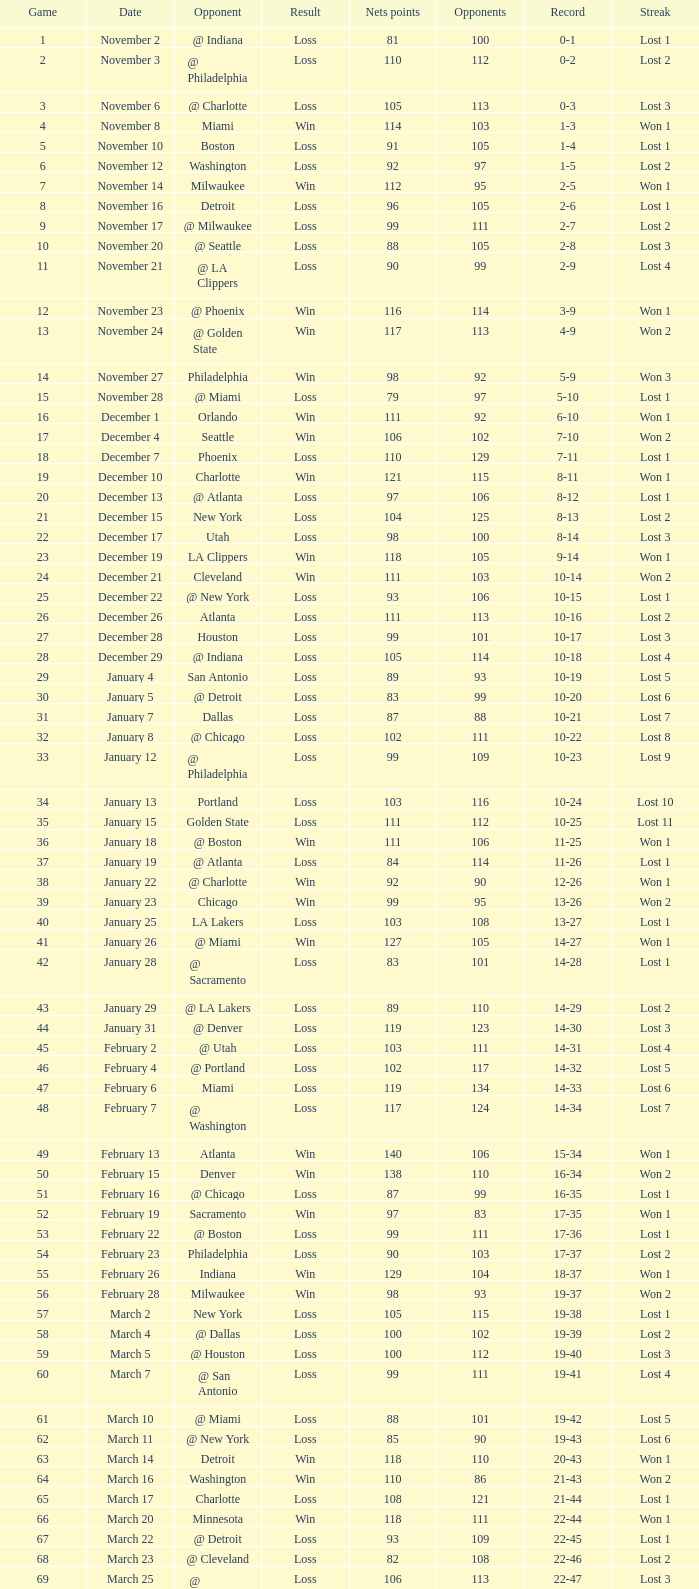Could you parse the entire table as a dict? {'header': ['Game', 'Date', 'Opponent', 'Result', 'Nets points', 'Opponents', 'Record', 'Streak'], 'rows': [['1', 'November 2', '@ Indiana', 'Loss', '81', '100', '0-1', 'Lost 1'], ['2', 'November 3', '@ Philadelphia', 'Loss', '110', '112', '0-2', 'Lost 2'], ['3', 'November 6', '@ Charlotte', 'Loss', '105', '113', '0-3', 'Lost 3'], ['4', 'November 8', 'Miami', 'Win', '114', '103', '1-3', 'Won 1'], ['5', 'November 10', 'Boston', 'Loss', '91', '105', '1-4', 'Lost 1'], ['6', 'November 12', 'Washington', 'Loss', '92', '97', '1-5', 'Lost 2'], ['7', 'November 14', 'Milwaukee', 'Win', '112', '95', '2-5', 'Won 1'], ['8', 'November 16', 'Detroit', 'Loss', '96', '105', '2-6', 'Lost 1'], ['9', 'November 17', '@ Milwaukee', 'Loss', '99', '111', '2-7', 'Lost 2'], ['10', 'November 20', '@ Seattle', 'Loss', '88', '105', '2-8', 'Lost 3'], ['11', 'November 21', '@ LA Clippers', 'Loss', '90', '99', '2-9', 'Lost 4'], ['12', 'November 23', '@ Phoenix', 'Win', '116', '114', '3-9', 'Won 1'], ['13', 'November 24', '@ Golden State', 'Win', '117', '113', '4-9', 'Won 2'], ['14', 'November 27', 'Philadelphia', 'Win', '98', '92', '5-9', 'Won 3'], ['15', 'November 28', '@ Miami', 'Loss', '79', '97', '5-10', 'Lost 1'], ['16', 'December 1', 'Orlando', 'Win', '111', '92', '6-10', 'Won 1'], ['17', 'December 4', 'Seattle', 'Win', '106', '102', '7-10', 'Won 2'], ['18', 'December 7', 'Phoenix', 'Loss', '110', '129', '7-11', 'Lost 1'], ['19', 'December 10', 'Charlotte', 'Win', '121', '115', '8-11', 'Won 1'], ['20', 'December 13', '@ Atlanta', 'Loss', '97', '106', '8-12', 'Lost 1'], ['21', 'December 15', 'New York', 'Loss', '104', '125', '8-13', 'Lost 2'], ['22', 'December 17', 'Utah', 'Loss', '98', '100', '8-14', 'Lost 3'], ['23', 'December 19', 'LA Clippers', 'Win', '118', '105', '9-14', 'Won 1'], ['24', 'December 21', 'Cleveland', 'Win', '111', '103', '10-14', 'Won 2'], ['25', 'December 22', '@ New York', 'Loss', '93', '106', '10-15', 'Lost 1'], ['26', 'December 26', 'Atlanta', 'Loss', '111', '113', '10-16', 'Lost 2'], ['27', 'December 28', 'Houston', 'Loss', '99', '101', '10-17', 'Lost 3'], ['28', 'December 29', '@ Indiana', 'Loss', '105', '114', '10-18', 'Lost 4'], ['29', 'January 4', 'San Antonio', 'Loss', '89', '93', '10-19', 'Lost 5'], ['30', 'January 5', '@ Detroit', 'Loss', '83', '99', '10-20', 'Lost 6'], ['31', 'January 7', 'Dallas', 'Loss', '87', '88', '10-21', 'Lost 7'], ['32', 'January 8', '@ Chicago', 'Loss', '102', '111', '10-22', 'Lost 8'], ['33', 'January 12', '@ Philadelphia', 'Loss', '99', '109', '10-23', 'Lost 9'], ['34', 'January 13', 'Portland', 'Loss', '103', '116', '10-24', 'Lost 10'], ['35', 'January 15', 'Golden State', 'Loss', '111', '112', '10-25', 'Lost 11'], ['36', 'January 18', '@ Boston', 'Win', '111', '106', '11-25', 'Won 1'], ['37', 'January 19', '@ Atlanta', 'Loss', '84', '114', '11-26', 'Lost 1'], ['38', 'January 22', '@ Charlotte', 'Win', '92', '90', '12-26', 'Won 1'], ['39', 'January 23', 'Chicago', 'Win', '99', '95', '13-26', 'Won 2'], ['40', 'January 25', 'LA Lakers', 'Loss', '103', '108', '13-27', 'Lost 1'], ['41', 'January 26', '@ Miami', 'Win', '127', '105', '14-27', 'Won 1'], ['42', 'January 28', '@ Sacramento', 'Loss', '83', '101', '14-28', 'Lost 1'], ['43', 'January 29', '@ LA Lakers', 'Loss', '89', '110', '14-29', 'Lost 2'], ['44', 'January 31', '@ Denver', 'Loss', '119', '123', '14-30', 'Lost 3'], ['45', 'February 2', '@ Utah', 'Loss', '103', '111', '14-31', 'Lost 4'], ['46', 'February 4', '@ Portland', 'Loss', '102', '117', '14-32', 'Lost 5'], ['47', 'February 6', 'Miami', 'Loss', '119', '134', '14-33', 'Lost 6'], ['48', 'February 7', '@ Washington', 'Loss', '117', '124', '14-34', 'Lost 7'], ['49', 'February 13', 'Atlanta', 'Win', '140', '106', '15-34', 'Won 1'], ['50', 'February 15', 'Denver', 'Win', '138', '110', '16-34', 'Won 2'], ['51', 'February 16', '@ Chicago', 'Loss', '87', '99', '16-35', 'Lost 1'], ['52', 'February 19', 'Sacramento', 'Win', '97', '83', '17-35', 'Won 1'], ['53', 'February 22', '@ Boston', 'Loss', '99', '111', '17-36', 'Lost 1'], ['54', 'February 23', 'Philadelphia', 'Loss', '90', '103', '17-37', 'Lost 2'], ['55', 'February 26', 'Indiana', 'Win', '129', '104', '18-37', 'Won 1'], ['56', 'February 28', 'Milwaukee', 'Win', '98', '93', '19-37', 'Won 2'], ['57', 'March 2', 'New York', 'Loss', '105', '115', '19-38', 'Lost 1'], ['58', 'March 4', '@ Dallas', 'Loss', '100', '102', '19-39', 'Lost 2'], ['59', 'March 5', '@ Houston', 'Loss', '100', '112', '19-40', 'Lost 3'], ['60', 'March 7', '@ San Antonio', 'Loss', '99', '111', '19-41', 'Lost 4'], ['61', 'March 10', '@ Miami', 'Loss', '88', '101', '19-42', 'Lost 5'], ['62', 'March 11', '@ New York', 'Loss', '85', '90', '19-43', 'Lost 6'], ['63', 'March 14', 'Detroit', 'Win', '118', '110', '20-43', 'Won 1'], ['64', 'March 16', 'Washington', 'Win', '110', '86', '21-43', 'Won 2'], ['65', 'March 17', 'Charlotte', 'Loss', '108', '121', '21-44', 'Lost 1'], ['66', 'March 20', 'Minnesota', 'Win', '118', '111', '22-44', 'Won 1'], ['67', 'March 22', '@ Detroit', 'Loss', '93', '109', '22-45', 'Lost 1'], ['68', 'March 23', '@ Cleveland', 'Loss', '82', '108', '22-46', 'Lost 2'], ['69', 'March 25', '@ Washington', 'Loss', '106', '113', '22-47', 'Lost 3'], ['70', 'March 26', 'Philadelphia', 'Win', '98', '95', '23-47', 'Won 1'], ['71', 'March 28', 'Chicago', 'Loss', '94', '128', '23-48', 'Lost 1'], ['72', 'March 30', 'New York', 'Loss', '117', '130', '23-49', 'Lost 2'], ['73', 'April 2', 'Boston', 'Loss', '77', '94', '23-50', 'Lost 3'], ['74', 'April 4', '@ Boston', 'Loss', '104', '123', '23-51', 'Lost 4'], ['75', 'April 6', '@ Milwaukee', 'Loss', '114', '133', '23-52', 'Lost 5'], ['76', 'April 9', '@ Minnesota', 'Loss', '89', '109', '23-53', 'Lost 6'], ['77', 'April 12', 'Cleveland', 'Win', '104', '103', '24-53', 'Won 1'], ['78', 'April 13', '@ Cleveland', 'Loss', '98', '102', '24-54', 'Lost 1'], ['79', 'April 16', 'Indiana', 'Loss', '126', '132', '24-55', 'Lost 2'], ['80', 'April 18', '@ Washington', 'Win', '108', '103', '25-55', 'Won 1'], ['81', 'April 20', 'Miami', 'Win', '118', '103', '26-55', 'Won 2'], ['82', 'April 21', '@ Orlando', 'Loss', '110', '120', '26-56', 'Lost 1']]} What was the average point total for the nets in games before game 9 where the opponents scored less than 95? None. 